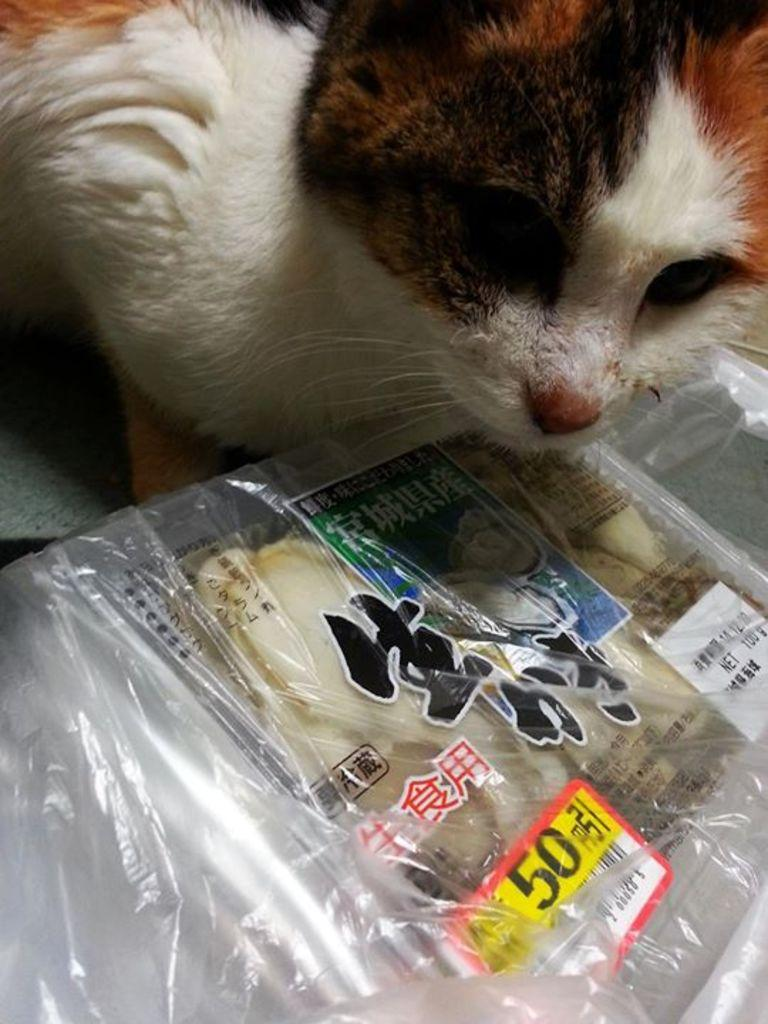What type of animal is in the picture? There is a cat in the picture. What is placed in front of the cat? Food is placed in front of the cat. What type of plastic material is visible in the image? There is no plastic material visible in the image. 